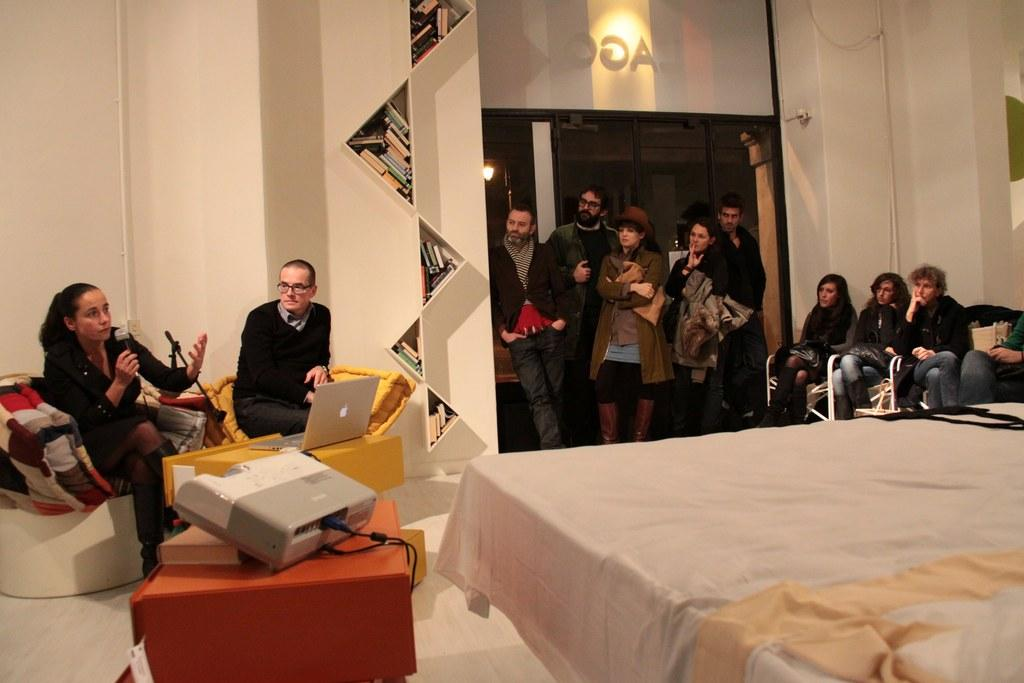What are the people in the image doing? There are people sitting and standing in the image. What can be seen on the shelves in the image? The shelves are filled with books in the image. What device is present for displaying visuals in the image? There is a projector in the image. What electronic device is visible in the image? There is a laptop in the image. What type of egg is being cooked on the grass in the image? There is no egg or grass present in the image; it features people, shelves with books, a projector, and a laptop. 